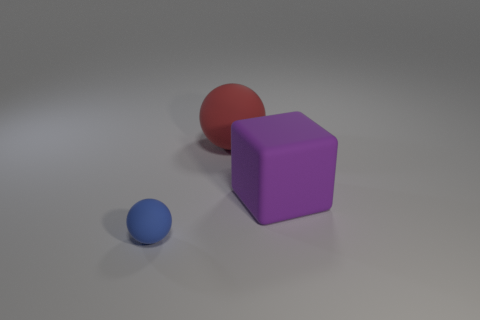Add 1 small green cylinders. How many objects exist? 4 Subtract all spheres. How many objects are left? 1 Add 1 red things. How many red things are left? 2 Add 3 large red spheres. How many large red spheres exist? 4 Subtract 0 gray cubes. How many objects are left? 3 Subtract all large yellow metal balls. Subtract all big spheres. How many objects are left? 2 